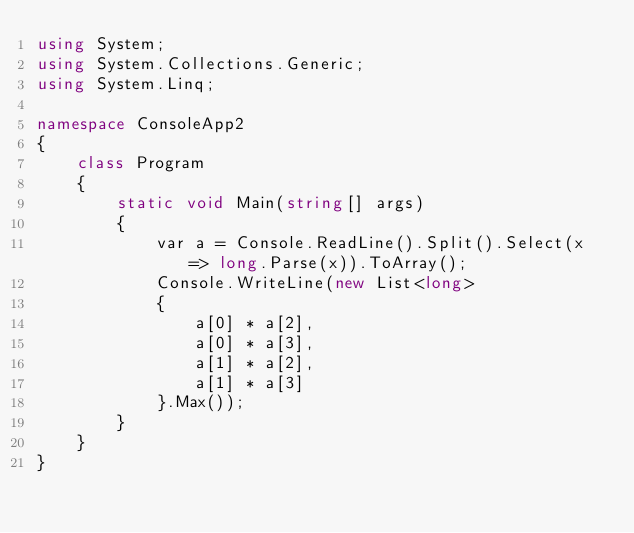<code> <loc_0><loc_0><loc_500><loc_500><_C#_>using System;
using System.Collections.Generic;
using System.Linq;

namespace ConsoleApp2
{
    class Program
    {
        static void Main(string[] args)
        {
            var a = Console.ReadLine().Split().Select(x => long.Parse(x)).ToArray();
            Console.WriteLine(new List<long>
            {
                a[0] * a[2],
                a[0] * a[3],
                a[1] * a[2],
                a[1] * a[3]
            }.Max());
        }
    }
}</code> 